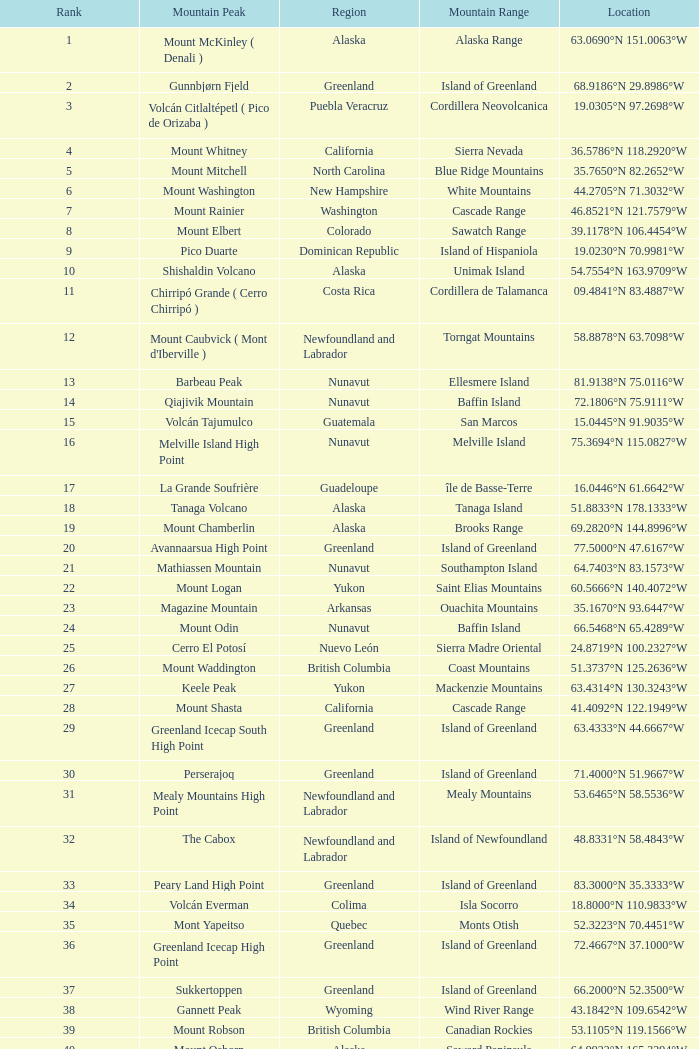At 28.1301°n 115.2206°w, which mountain peak can be found in the baja california region? Isla Cedros High Point. 